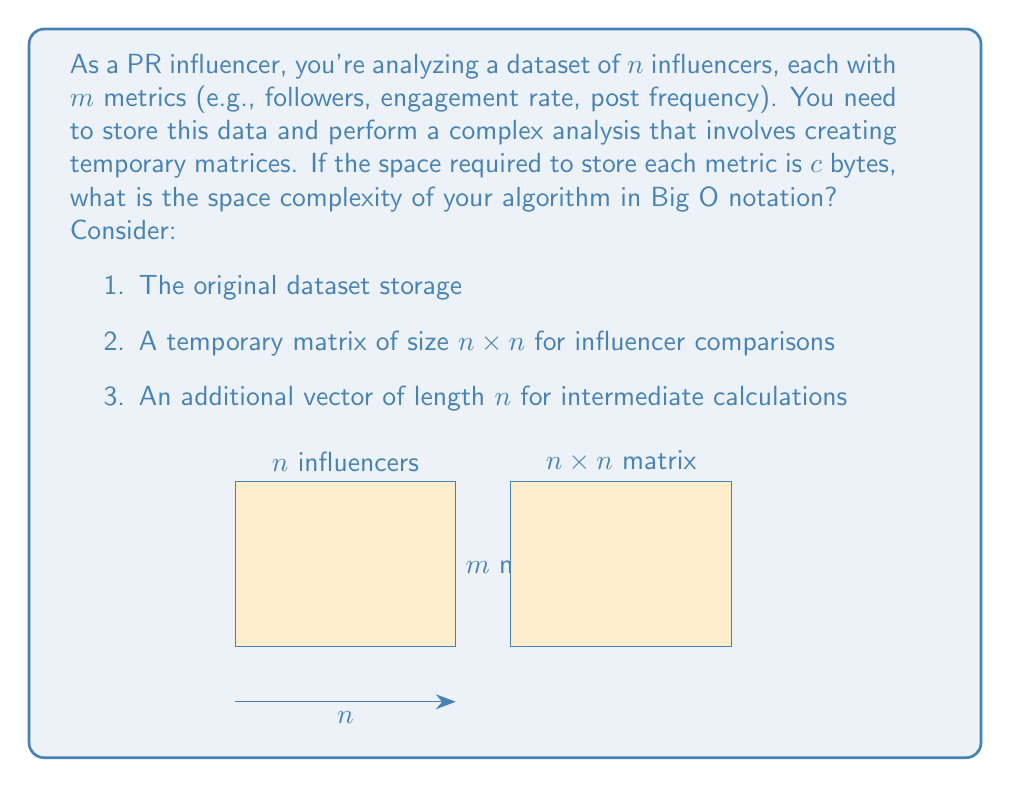Solve this math problem. Let's break down the space requirements step-by-step:

1. Original dataset storage:
   - We have $n$ influencers, each with $m$ metrics
   - Each metric requires $c$ bytes of storage
   - Total space for the dataset: $n \times m \times c$ bytes

2. Temporary matrix for influencer comparisons:
   - Size of the matrix: $n \times n$
   - Each element likely requires constant space, let's say $d$ bytes
   - Total space for the matrix: $n \times n \times d$ bytes

3. Additional vector for intermediate calculations:
   - Length of the vector: $n$
   - Each element requires constant space, let's say $e$ bytes
   - Total space for the vector: $n \times e$ bytes

Now, let's combine these components:

Total space = $n \times m \times c + n \times n \times d + n \times e$
            = $nmc + n^2d + ne$

To determine the space complexity in Big O notation, we need to identify the dominant term as $n$ grows large. Since $m$, $c$, $d$, and $e$ are constants:

- $nmc$ grows linearly with $n$
- $n^2d$ grows quadratically with $n$
- $ne$ grows linearly with $n$

The quadratic term $n^2d$ dominates as $n$ becomes large. Therefore, the space complexity is $O(n^2)$.
Answer: $O(n^2)$ 